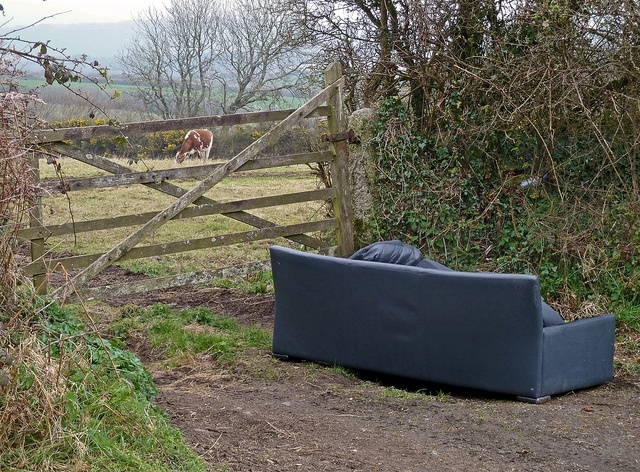Describe the objects in this image and their specific colors. I can see couch in white, black, darkblue, and gray tones and cow in white, brown, darkgray, and lightgray tones in this image. 